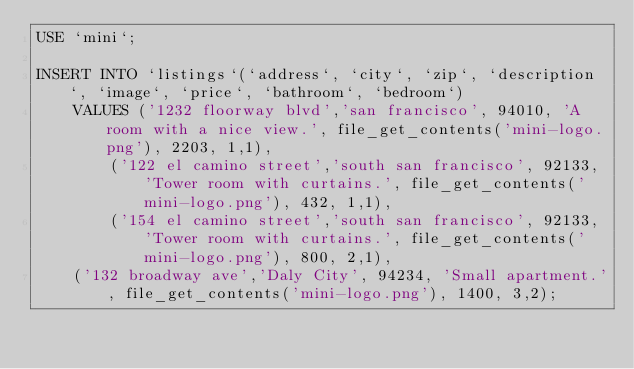Convert code to text. <code><loc_0><loc_0><loc_500><loc_500><_SQL_>USE `mini`;

INSERT INTO `listings`(`address`, `city`, `zip`, `description`, `image`, `price`, `bathroom`, `bedroom`)
    VALUES ('1232 floorway blvd','san francisco', 94010, 'A room with a nice view.', file_get_contents('mini-logo.png'), 2203, 1,1),
        ('122 el camino street','south san francisco', 92133, 'Tower room with curtains.', file_get_contents('mini-logo.png'), 432, 1,1),
        ('154 el camino street','south san francisco', 92133, 'Tower room with curtains.', file_get_contents('mini-logo.png'), 800, 2,1),
    ('132 broadway ave','Daly City', 94234, 'Small apartment.', file_get_contents('mini-logo.png'), 1400, 3,2);</code> 